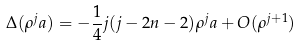<formula> <loc_0><loc_0><loc_500><loc_500>\Delta ( \rho ^ { j } a ) = - \frac { 1 } { 4 } j ( j - 2 n - 2 ) \rho ^ { j } a + O ( \rho ^ { j + 1 } )</formula> 